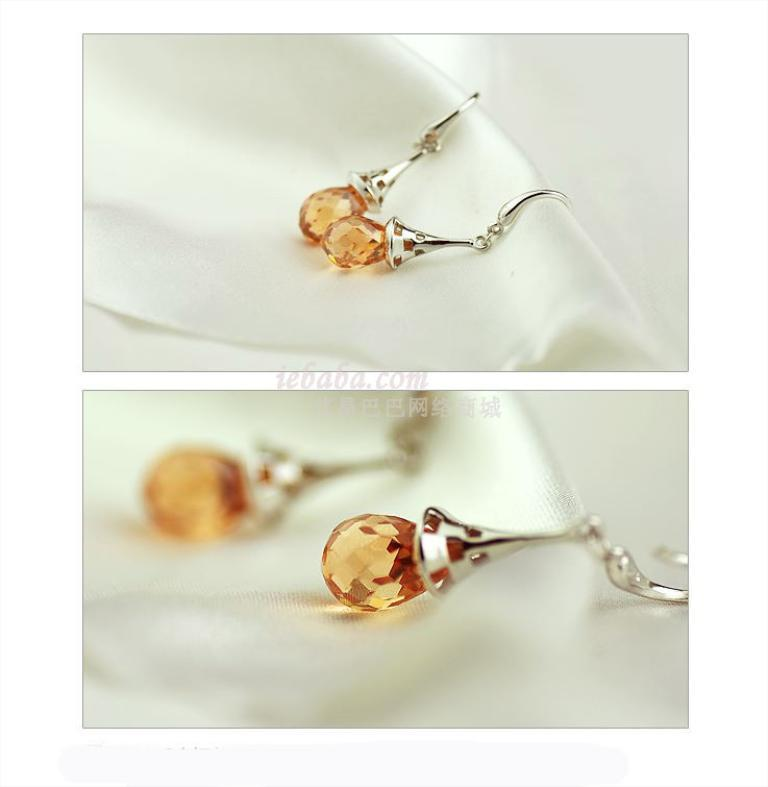What type of jewelry is present in the image? There are earrings in the picture. What is the color of the earrings? The earrings are silver in color. What additional feature can be seen on the earrings? The earrings have orange color gems attached to them. On what surface are the earrings placed? The earrings are placed on a white cloth. How many thumbs are visible in the image? There are no thumbs visible in the image; it only features earrings placed on a white cloth. What type of sponge is used to clean the gems on the earrings? There is no sponge present in the image, and the cleaning method for the gems is not mentioned. 